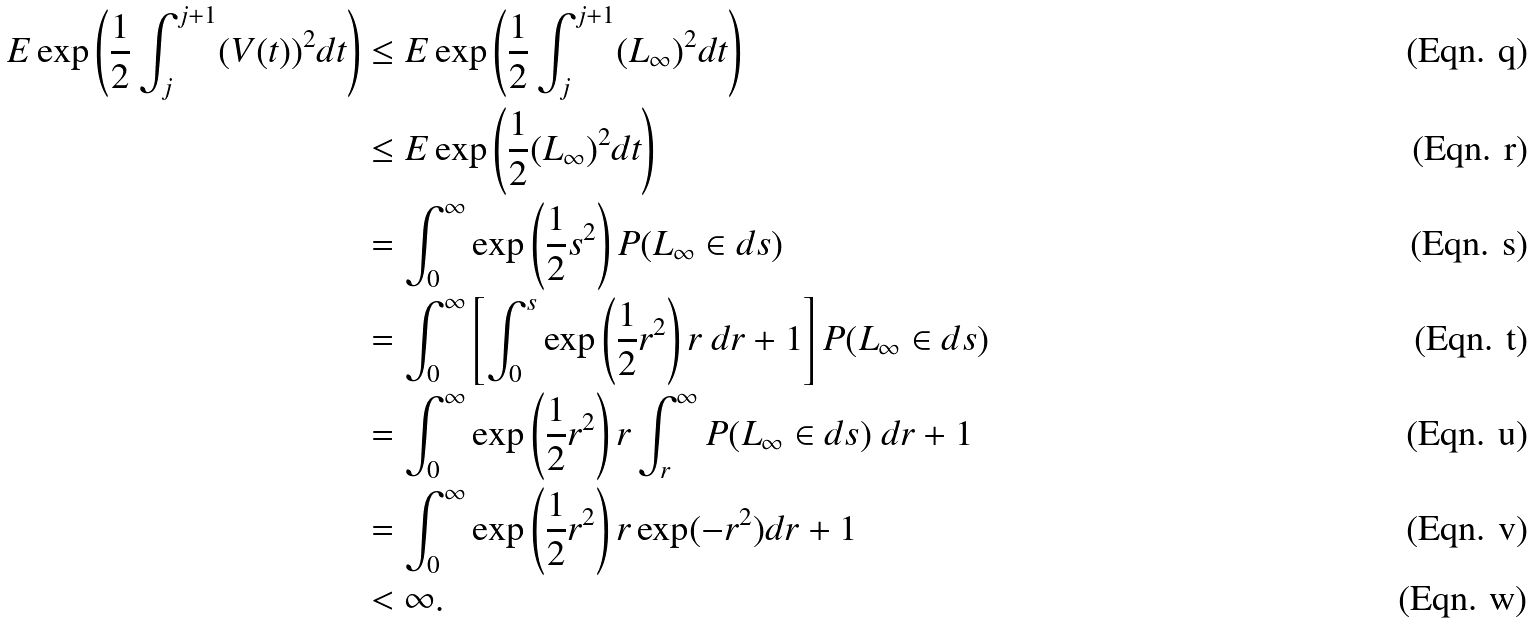<formula> <loc_0><loc_0><loc_500><loc_500>E \exp \left ( \frac { 1 } { 2 } \int _ { j } ^ { j + 1 } ( V ( t ) ) ^ { 2 } d t \right ) & \leq E \exp \left ( \frac { 1 } { 2 } \int _ { j } ^ { j + 1 } ( L _ { \infty } ) ^ { 2 } d t \right ) \\ & \leq E \exp \left ( \frac { 1 } { 2 } ( L _ { \infty } ) ^ { 2 } d t \right ) \\ & = \int _ { 0 } ^ { \infty } \exp \left ( \frac { 1 } { 2 } s ^ { 2 } \right ) P ( L _ { \infty } \in d s ) \\ & = \int _ { 0 } ^ { \infty } \left [ \int _ { 0 } ^ { s } \exp \left ( \frac { 1 } { 2 } r ^ { 2 } \right ) r \ d r + 1 \right ] P ( L _ { \infty } \in d s ) \\ & = \int _ { 0 } ^ { \infty } \exp \left ( \frac { 1 } { 2 } r ^ { 2 } \right ) r \int _ { r } ^ { \infty } P ( L _ { \infty } \in d s ) \ d r + 1 \\ & = \int _ { 0 } ^ { \infty } \exp \left ( \frac { 1 } { 2 } r ^ { 2 } \right ) r \exp ( - r ^ { 2 } ) d r + 1 \\ & < \infty .</formula> 